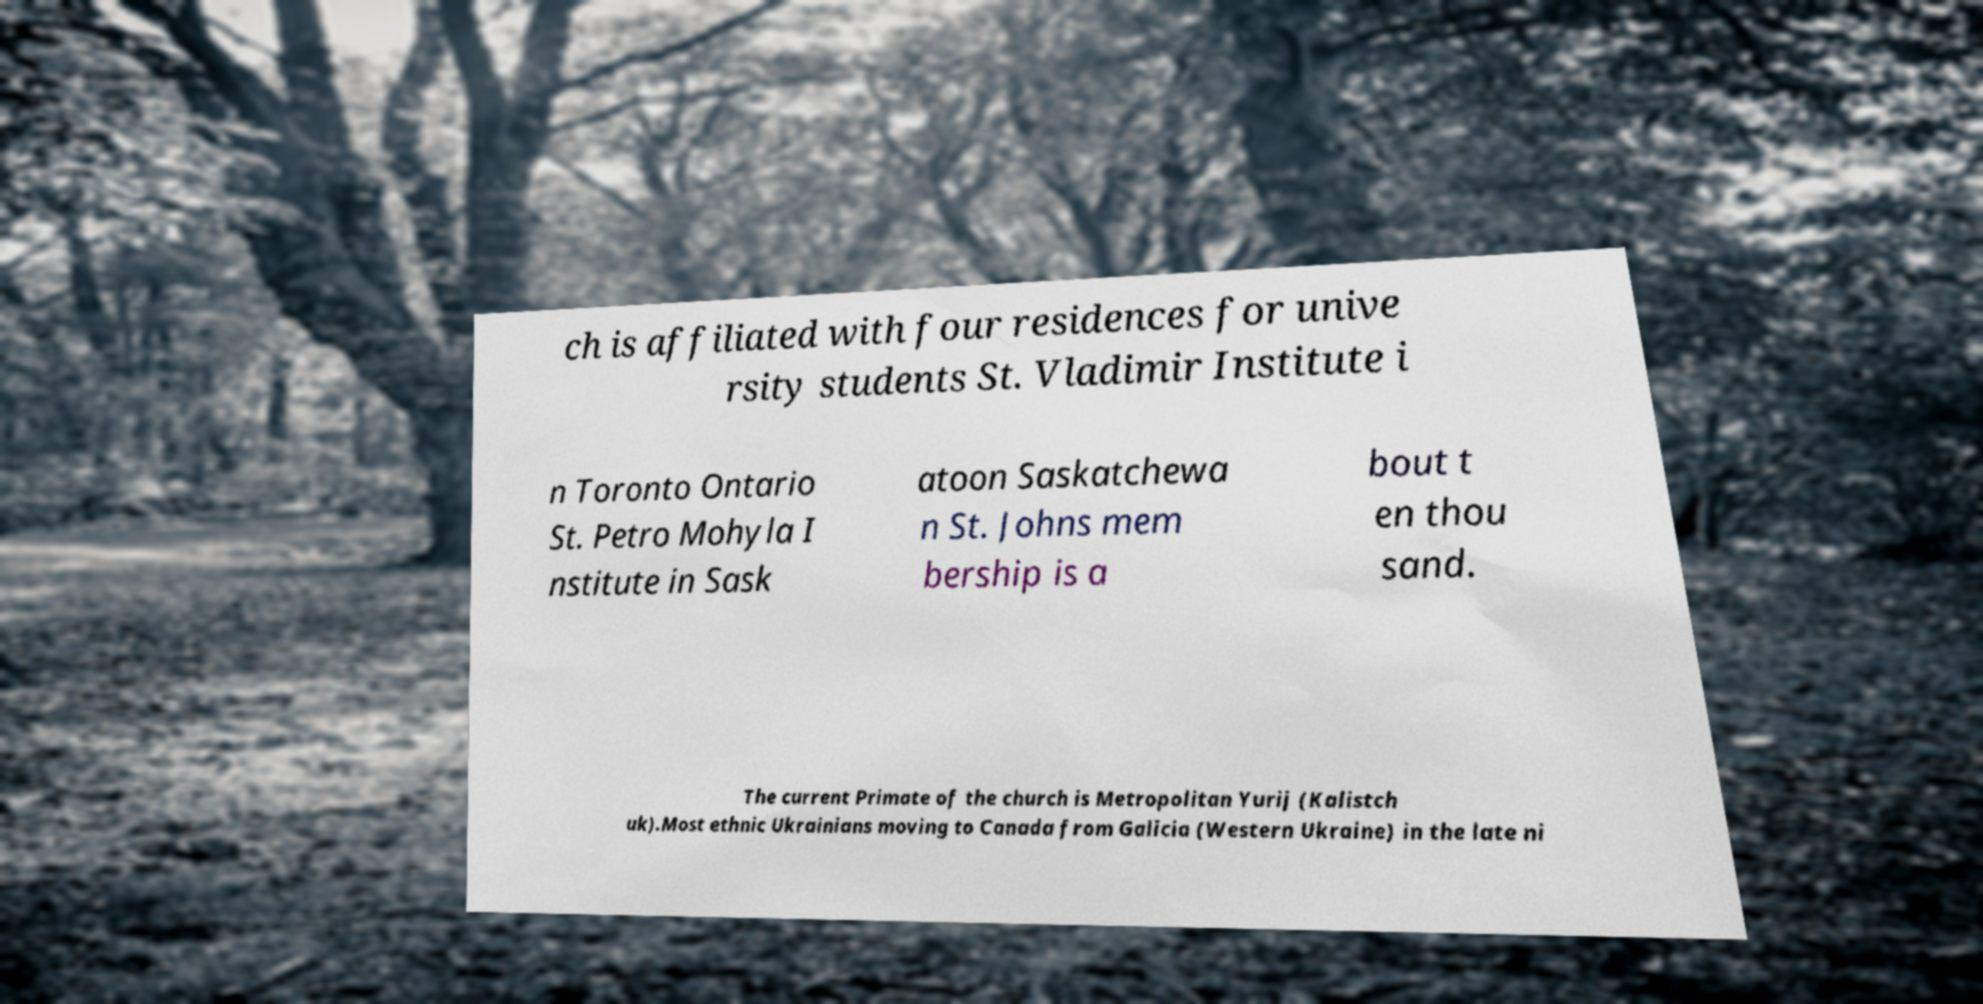There's text embedded in this image that I need extracted. Can you transcribe it verbatim? ch is affiliated with four residences for unive rsity students St. Vladimir Institute i n Toronto Ontario St. Petro Mohyla I nstitute in Sask atoon Saskatchewa n St. Johns mem bership is a bout t en thou sand. The current Primate of the church is Metropolitan Yurij (Kalistch uk).Most ethnic Ukrainians moving to Canada from Galicia (Western Ukraine) in the late ni 